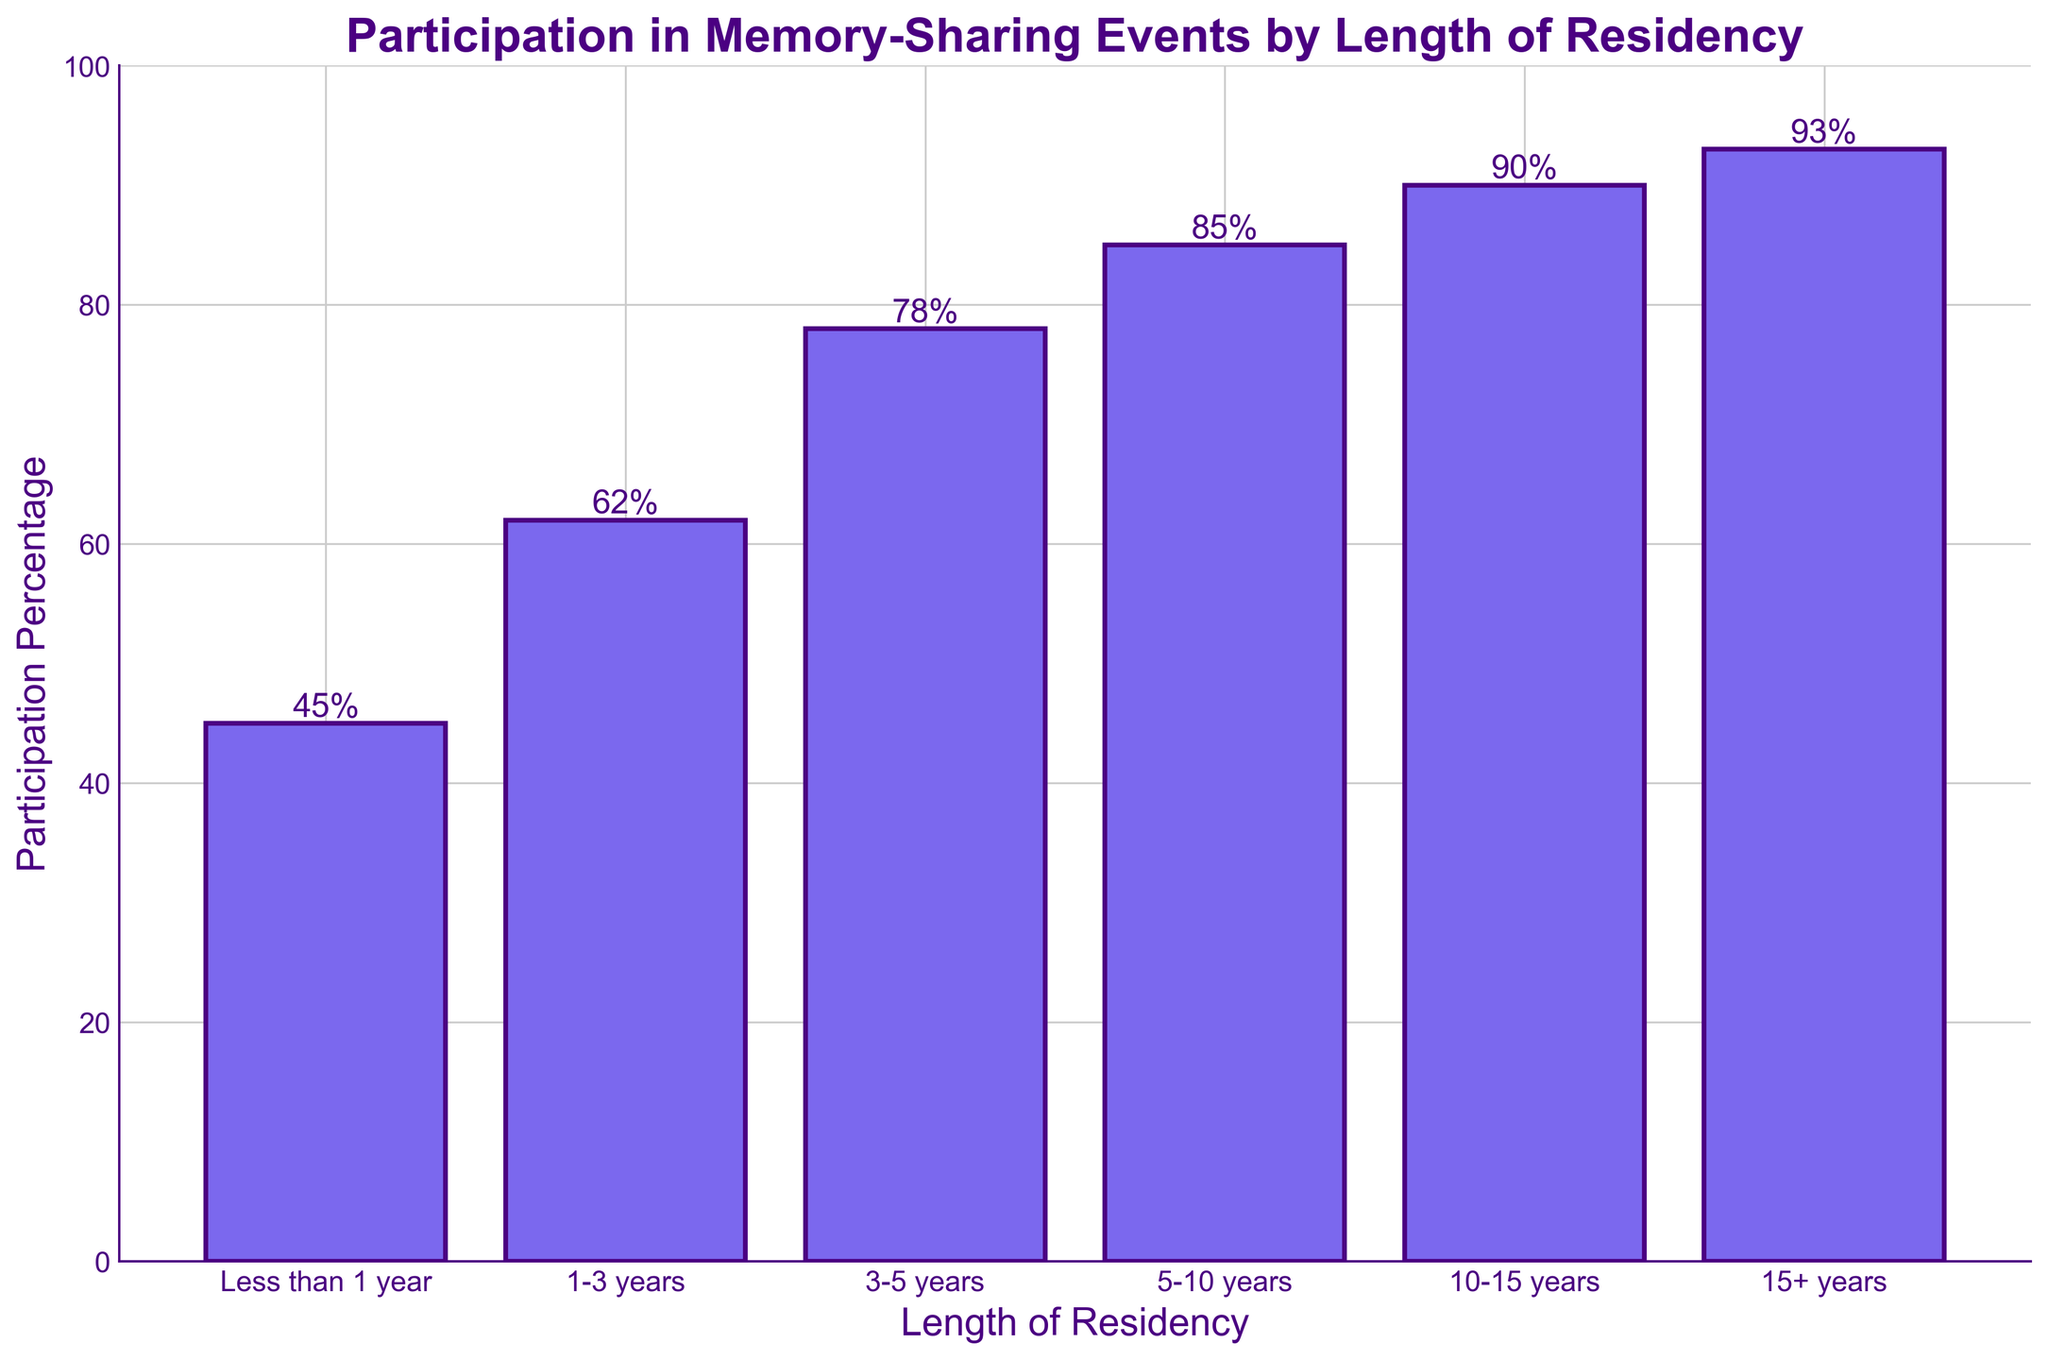what is the participation percentage for residents who have lived in the community for 15+ years? To find the percentage, look at the bar labeled "15+ years" and read the height of the bar, which shows the percentage value.
Answer: 93% How much higher is the participation percentage for residents who have lived 10-15 years compared to those less than 1 year? Compare the heights of the bars for "10-15 years" and "Less than 1 year". The "10-15 years" bar is at 90%, while the "Less than 1 year" bar is at 45%. The difference is calculated as 90% - 45%.
Answer: 45% What is the average participation percentage of residents who have lived between 1-5 years? Add the percentages for "1-3 years" and "3-5 years" and divide by the number of data points. This calculation is (62% + 78%) / 2.
Answer: 70% Which length of residency shows the highest participation percentage in memory-sharing events? Observe the heights of all the bars and identify the bar with the highest value. The bar for "15+ years" is the tallest at 93%.
Answer: 15+ years By what percentage does participation increase from residents who have lived 5-10 years to those who have lived 15+ years? Compare the bars for "5-10 years" and "15+ years". The "5-10 years" bar is at 85%, and the "15+ years" bar is at 93%. The increase is calculated as 93% - 85%.
Answer: 8% Which two consecutive residency periods had the largest gain in participation percentage? Look at the differences between consecutive bars and find the largest. For example, from "Less than 1 year" (45%) to "1-3 years" (62%) is 17%, and compare it with other consecutive differences. The largest gain is between "3-5 years" (78%) to "5-10 years" (85%) at 7%.
Answer: Less than 1 year to 1-3 years What is the range of participation percentages among all residency groups? Subtract the smallest participation percentage from the largest. The smallest is 45% (Less than 1 year) and the largest is 93% (15+ years). The range is 93% - 45%.
Answer: 48% If a new resident moves in and attends a memory-sharing event after living 1 year, will they most likely be part of a higher or lower participation group than someone who’s lived 10-15 years? Look at the height of the bars for "1-3 years" and "10-15 years". The participation for "10-15 years" (90%) is higher than "1-3 years" (62%).
Answer: Lower What is the median participation percentage for the groups represented in the bar chart? List the participation percentages in order: 45%, 62%, 78%, 85%, 90%, 93%. The median is the average of the middle two values: (78% + 85%) / 2.
Answer: 81.5% 